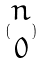<formula> <loc_0><loc_0><loc_500><loc_500>( \begin{matrix} n \\ 0 \end{matrix} )</formula> 